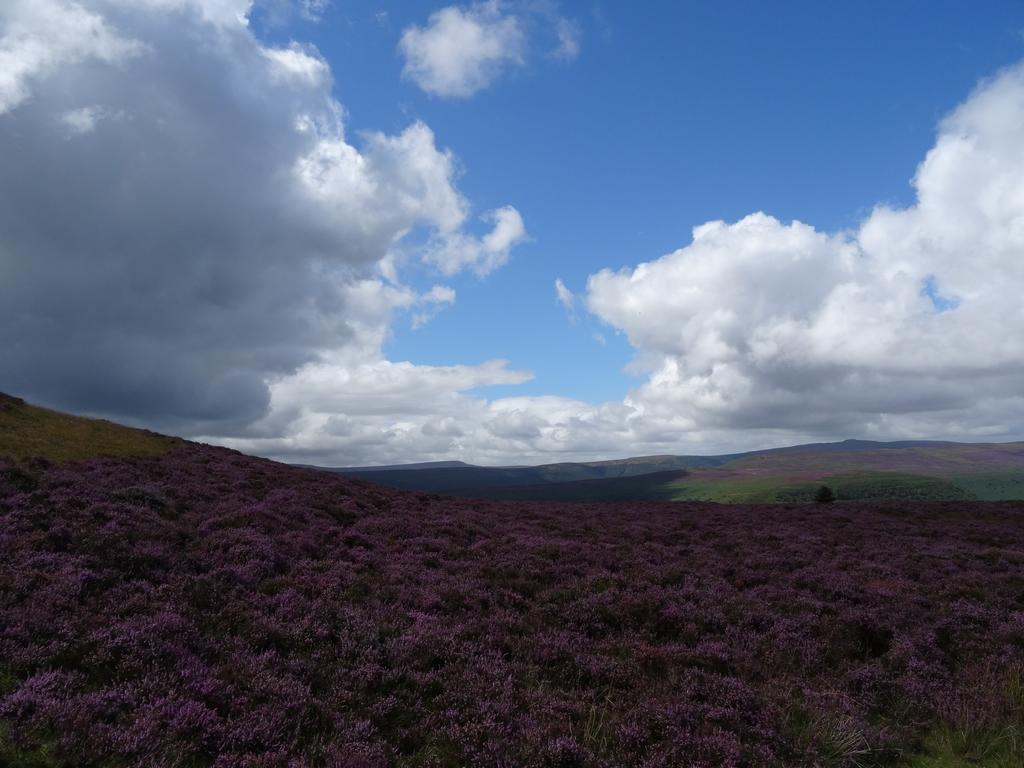How would you summarize this image in a sentence or two? In the picture I can see planets, hills and the sky with clouds in the background. 